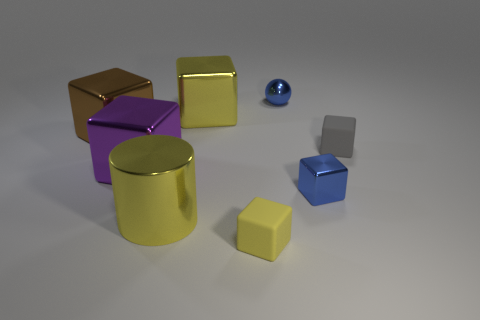Subtract all large brown blocks. How many blocks are left? 5 Subtract all blue cubes. How many cubes are left? 5 Add 1 blue matte spheres. How many objects exist? 9 Subtract all spheres. How many objects are left? 7 Add 6 big purple objects. How many big purple objects exist? 7 Subtract 0 brown cylinders. How many objects are left? 8 Subtract 1 cylinders. How many cylinders are left? 0 Subtract all yellow blocks. Subtract all brown cylinders. How many blocks are left? 4 Subtract all purple balls. How many gray cylinders are left? 0 Subtract all blue things. Subtract all brown cylinders. How many objects are left? 6 